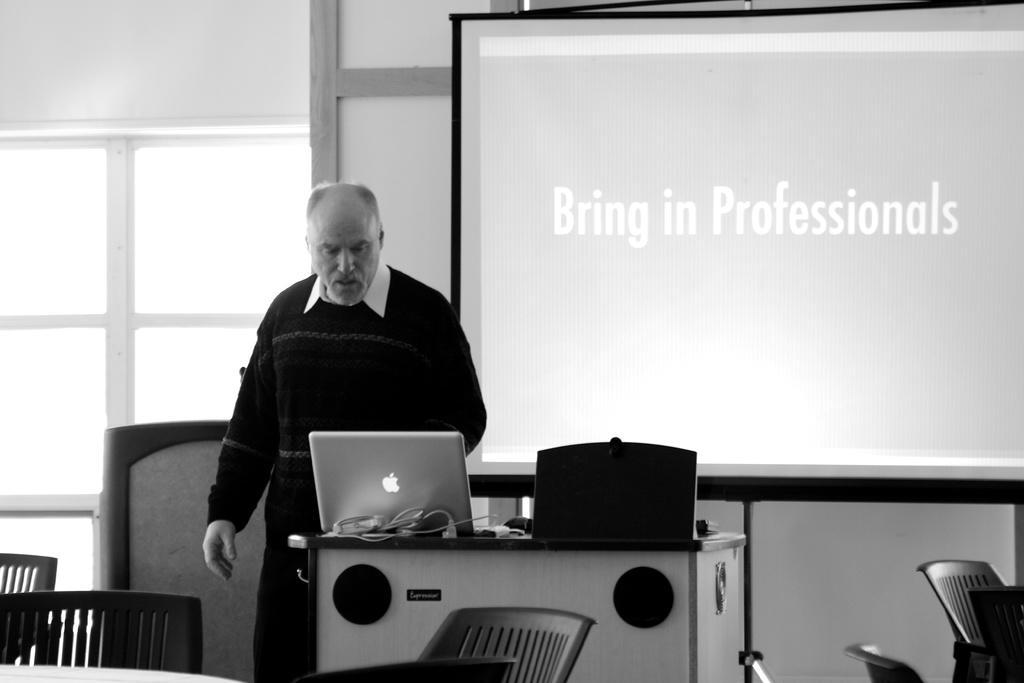In one or two sentences, can you explain what this image depicts? In the middle of the image a man is standing and watching into the laptop. Laptop is on the table. Bottom right side of the image there are some chairs. Top right side of the image there is a screen. Top left side of the image there is a window and wall. Bottom left side of the image there are two chairs. 